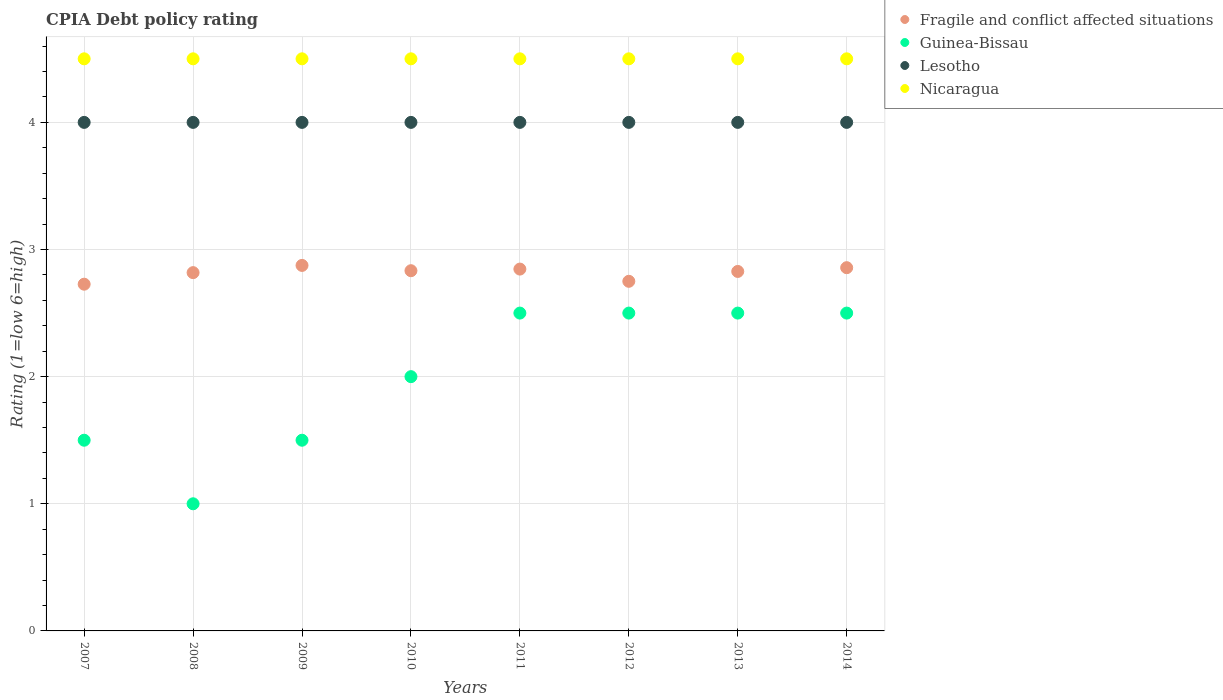Is the number of dotlines equal to the number of legend labels?
Provide a succinct answer. Yes. Across all years, what is the maximum CPIA rating in Lesotho?
Your response must be concise. 4. Across all years, what is the minimum CPIA rating in Lesotho?
Your answer should be very brief. 4. What is the total CPIA rating in Lesotho in the graph?
Keep it short and to the point. 32. In the year 2007, what is the difference between the CPIA rating in Fragile and conflict affected situations and CPIA rating in Guinea-Bissau?
Offer a very short reply. 1.23. In how many years, is the CPIA rating in Guinea-Bissau greater than 4.4?
Give a very brief answer. 0. Is the CPIA rating in Fragile and conflict affected situations in 2010 less than that in 2013?
Provide a succinct answer. No. Is the difference between the CPIA rating in Fragile and conflict affected situations in 2007 and 2009 greater than the difference between the CPIA rating in Guinea-Bissau in 2007 and 2009?
Keep it short and to the point. No. Is the sum of the CPIA rating in Nicaragua in 2008 and 2014 greater than the maximum CPIA rating in Guinea-Bissau across all years?
Provide a short and direct response. Yes. How many dotlines are there?
Ensure brevity in your answer.  4. Does the graph contain any zero values?
Provide a short and direct response. No. Where does the legend appear in the graph?
Give a very brief answer. Top right. How many legend labels are there?
Provide a short and direct response. 4. What is the title of the graph?
Offer a very short reply. CPIA Debt policy rating. Does "Luxembourg" appear as one of the legend labels in the graph?
Provide a succinct answer. No. What is the Rating (1=low 6=high) of Fragile and conflict affected situations in 2007?
Your answer should be very brief. 2.73. What is the Rating (1=low 6=high) in Nicaragua in 2007?
Provide a succinct answer. 4.5. What is the Rating (1=low 6=high) in Fragile and conflict affected situations in 2008?
Your response must be concise. 2.82. What is the Rating (1=low 6=high) of Lesotho in 2008?
Make the answer very short. 4. What is the Rating (1=low 6=high) of Fragile and conflict affected situations in 2009?
Provide a succinct answer. 2.88. What is the Rating (1=low 6=high) in Lesotho in 2009?
Provide a short and direct response. 4. What is the Rating (1=low 6=high) of Fragile and conflict affected situations in 2010?
Provide a short and direct response. 2.83. What is the Rating (1=low 6=high) in Guinea-Bissau in 2010?
Provide a short and direct response. 2. What is the Rating (1=low 6=high) in Nicaragua in 2010?
Give a very brief answer. 4.5. What is the Rating (1=low 6=high) in Fragile and conflict affected situations in 2011?
Your response must be concise. 2.85. What is the Rating (1=low 6=high) in Nicaragua in 2011?
Keep it short and to the point. 4.5. What is the Rating (1=low 6=high) of Fragile and conflict affected situations in 2012?
Provide a short and direct response. 2.75. What is the Rating (1=low 6=high) in Guinea-Bissau in 2012?
Provide a succinct answer. 2.5. What is the Rating (1=low 6=high) of Lesotho in 2012?
Your answer should be very brief. 4. What is the Rating (1=low 6=high) in Fragile and conflict affected situations in 2013?
Provide a short and direct response. 2.83. What is the Rating (1=low 6=high) in Guinea-Bissau in 2013?
Your answer should be compact. 2.5. What is the Rating (1=low 6=high) of Fragile and conflict affected situations in 2014?
Your answer should be very brief. 2.86. What is the Rating (1=low 6=high) in Guinea-Bissau in 2014?
Keep it short and to the point. 2.5. Across all years, what is the maximum Rating (1=low 6=high) of Fragile and conflict affected situations?
Offer a terse response. 2.88. Across all years, what is the maximum Rating (1=low 6=high) in Guinea-Bissau?
Give a very brief answer. 2.5. Across all years, what is the minimum Rating (1=low 6=high) of Fragile and conflict affected situations?
Provide a succinct answer. 2.73. Across all years, what is the minimum Rating (1=low 6=high) of Guinea-Bissau?
Give a very brief answer. 1. Across all years, what is the minimum Rating (1=low 6=high) in Nicaragua?
Provide a succinct answer. 4.5. What is the total Rating (1=low 6=high) in Fragile and conflict affected situations in the graph?
Give a very brief answer. 22.53. What is the total Rating (1=low 6=high) of Lesotho in the graph?
Provide a short and direct response. 32. What is the total Rating (1=low 6=high) of Nicaragua in the graph?
Keep it short and to the point. 36. What is the difference between the Rating (1=low 6=high) of Fragile and conflict affected situations in 2007 and that in 2008?
Offer a very short reply. -0.09. What is the difference between the Rating (1=low 6=high) in Lesotho in 2007 and that in 2008?
Provide a short and direct response. 0. What is the difference between the Rating (1=low 6=high) of Nicaragua in 2007 and that in 2008?
Offer a very short reply. 0. What is the difference between the Rating (1=low 6=high) in Fragile and conflict affected situations in 2007 and that in 2009?
Provide a succinct answer. -0.15. What is the difference between the Rating (1=low 6=high) of Lesotho in 2007 and that in 2009?
Ensure brevity in your answer.  0. What is the difference between the Rating (1=low 6=high) of Fragile and conflict affected situations in 2007 and that in 2010?
Offer a very short reply. -0.11. What is the difference between the Rating (1=low 6=high) in Fragile and conflict affected situations in 2007 and that in 2011?
Provide a succinct answer. -0.12. What is the difference between the Rating (1=low 6=high) in Guinea-Bissau in 2007 and that in 2011?
Keep it short and to the point. -1. What is the difference between the Rating (1=low 6=high) in Nicaragua in 2007 and that in 2011?
Make the answer very short. 0. What is the difference between the Rating (1=low 6=high) of Fragile and conflict affected situations in 2007 and that in 2012?
Offer a terse response. -0.02. What is the difference between the Rating (1=low 6=high) of Guinea-Bissau in 2007 and that in 2012?
Give a very brief answer. -1. What is the difference between the Rating (1=low 6=high) of Fragile and conflict affected situations in 2007 and that in 2013?
Ensure brevity in your answer.  -0.1. What is the difference between the Rating (1=low 6=high) of Lesotho in 2007 and that in 2013?
Give a very brief answer. 0. What is the difference between the Rating (1=low 6=high) of Nicaragua in 2007 and that in 2013?
Offer a very short reply. 0. What is the difference between the Rating (1=low 6=high) in Fragile and conflict affected situations in 2007 and that in 2014?
Ensure brevity in your answer.  -0.13. What is the difference between the Rating (1=low 6=high) in Guinea-Bissau in 2007 and that in 2014?
Your response must be concise. -1. What is the difference between the Rating (1=low 6=high) in Nicaragua in 2007 and that in 2014?
Your answer should be compact. 0. What is the difference between the Rating (1=low 6=high) of Fragile and conflict affected situations in 2008 and that in 2009?
Offer a very short reply. -0.06. What is the difference between the Rating (1=low 6=high) of Fragile and conflict affected situations in 2008 and that in 2010?
Offer a very short reply. -0.02. What is the difference between the Rating (1=low 6=high) of Nicaragua in 2008 and that in 2010?
Your answer should be compact. 0. What is the difference between the Rating (1=low 6=high) of Fragile and conflict affected situations in 2008 and that in 2011?
Your answer should be very brief. -0.03. What is the difference between the Rating (1=low 6=high) of Guinea-Bissau in 2008 and that in 2011?
Your answer should be very brief. -1.5. What is the difference between the Rating (1=low 6=high) in Nicaragua in 2008 and that in 2011?
Ensure brevity in your answer.  0. What is the difference between the Rating (1=low 6=high) of Fragile and conflict affected situations in 2008 and that in 2012?
Offer a very short reply. 0.07. What is the difference between the Rating (1=low 6=high) of Guinea-Bissau in 2008 and that in 2012?
Offer a terse response. -1.5. What is the difference between the Rating (1=low 6=high) of Nicaragua in 2008 and that in 2012?
Offer a terse response. 0. What is the difference between the Rating (1=low 6=high) in Fragile and conflict affected situations in 2008 and that in 2013?
Make the answer very short. -0.01. What is the difference between the Rating (1=low 6=high) of Lesotho in 2008 and that in 2013?
Give a very brief answer. 0. What is the difference between the Rating (1=low 6=high) in Nicaragua in 2008 and that in 2013?
Offer a very short reply. 0. What is the difference between the Rating (1=low 6=high) in Fragile and conflict affected situations in 2008 and that in 2014?
Offer a very short reply. -0.04. What is the difference between the Rating (1=low 6=high) in Guinea-Bissau in 2008 and that in 2014?
Offer a very short reply. -1.5. What is the difference between the Rating (1=low 6=high) in Nicaragua in 2008 and that in 2014?
Offer a very short reply. 0. What is the difference between the Rating (1=low 6=high) of Fragile and conflict affected situations in 2009 and that in 2010?
Your answer should be very brief. 0.04. What is the difference between the Rating (1=low 6=high) in Guinea-Bissau in 2009 and that in 2010?
Your answer should be compact. -0.5. What is the difference between the Rating (1=low 6=high) of Fragile and conflict affected situations in 2009 and that in 2011?
Your response must be concise. 0.03. What is the difference between the Rating (1=low 6=high) in Guinea-Bissau in 2009 and that in 2011?
Your answer should be compact. -1. What is the difference between the Rating (1=low 6=high) in Fragile and conflict affected situations in 2009 and that in 2012?
Your answer should be compact. 0.12. What is the difference between the Rating (1=low 6=high) of Guinea-Bissau in 2009 and that in 2012?
Your answer should be compact. -1. What is the difference between the Rating (1=low 6=high) of Lesotho in 2009 and that in 2012?
Your response must be concise. 0. What is the difference between the Rating (1=low 6=high) in Fragile and conflict affected situations in 2009 and that in 2013?
Offer a terse response. 0.05. What is the difference between the Rating (1=low 6=high) in Lesotho in 2009 and that in 2013?
Your response must be concise. 0. What is the difference between the Rating (1=low 6=high) of Fragile and conflict affected situations in 2009 and that in 2014?
Your answer should be very brief. 0.02. What is the difference between the Rating (1=low 6=high) in Guinea-Bissau in 2009 and that in 2014?
Your response must be concise. -1. What is the difference between the Rating (1=low 6=high) in Nicaragua in 2009 and that in 2014?
Your answer should be compact. 0. What is the difference between the Rating (1=low 6=high) in Fragile and conflict affected situations in 2010 and that in 2011?
Give a very brief answer. -0.01. What is the difference between the Rating (1=low 6=high) in Lesotho in 2010 and that in 2011?
Your response must be concise. 0. What is the difference between the Rating (1=low 6=high) in Nicaragua in 2010 and that in 2011?
Your response must be concise. 0. What is the difference between the Rating (1=low 6=high) in Fragile and conflict affected situations in 2010 and that in 2012?
Your response must be concise. 0.08. What is the difference between the Rating (1=low 6=high) in Lesotho in 2010 and that in 2012?
Provide a short and direct response. 0. What is the difference between the Rating (1=low 6=high) of Nicaragua in 2010 and that in 2012?
Provide a succinct answer. 0. What is the difference between the Rating (1=low 6=high) in Fragile and conflict affected situations in 2010 and that in 2013?
Give a very brief answer. 0.01. What is the difference between the Rating (1=low 6=high) of Lesotho in 2010 and that in 2013?
Provide a short and direct response. 0. What is the difference between the Rating (1=low 6=high) of Nicaragua in 2010 and that in 2013?
Offer a terse response. 0. What is the difference between the Rating (1=low 6=high) in Fragile and conflict affected situations in 2010 and that in 2014?
Keep it short and to the point. -0.02. What is the difference between the Rating (1=low 6=high) of Lesotho in 2010 and that in 2014?
Your answer should be very brief. 0. What is the difference between the Rating (1=low 6=high) in Fragile and conflict affected situations in 2011 and that in 2012?
Make the answer very short. 0.1. What is the difference between the Rating (1=low 6=high) in Fragile and conflict affected situations in 2011 and that in 2013?
Offer a terse response. 0.02. What is the difference between the Rating (1=low 6=high) in Fragile and conflict affected situations in 2011 and that in 2014?
Your answer should be very brief. -0.01. What is the difference between the Rating (1=low 6=high) in Guinea-Bissau in 2011 and that in 2014?
Provide a succinct answer. 0. What is the difference between the Rating (1=low 6=high) in Lesotho in 2011 and that in 2014?
Your answer should be compact. 0. What is the difference between the Rating (1=low 6=high) in Fragile and conflict affected situations in 2012 and that in 2013?
Give a very brief answer. -0.08. What is the difference between the Rating (1=low 6=high) in Guinea-Bissau in 2012 and that in 2013?
Your answer should be compact. 0. What is the difference between the Rating (1=low 6=high) in Lesotho in 2012 and that in 2013?
Provide a short and direct response. 0. What is the difference between the Rating (1=low 6=high) in Nicaragua in 2012 and that in 2013?
Offer a terse response. 0. What is the difference between the Rating (1=low 6=high) in Fragile and conflict affected situations in 2012 and that in 2014?
Your response must be concise. -0.11. What is the difference between the Rating (1=low 6=high) of Guinea-Bissau in 2012 and that in 2014?
Give a very brief answer. 0. What is the difference between the Rating (1=low 6=high) of Nicaragua in 2012 and that in 2014?
Make the answer very short. 0. What is the difference between the Rating (1=low 6=high) in Fragile and conflict affected situations in 2013 and that in 2014?
Provide a short and direct response. -0.03. What is the difference between the Rating (1=low 6=high) of Guinea-Bissau in 2013 and that in 2014?
Give a very brief answer. 0. What is the difference between the Rating (1=low 6=high) in Fragile and conflict affected situations in 2007 and the Rating (1=low 6=high) in Guinea-Bissau in 2008?
Your response must be concise. 1.73. What is the difference between the Rating (1=low 6=high) in Fragile and conflict affected situations in 2007 and the Rating (1=low 6=high) in Lesotho in 2008?
Your answer should be very brief. -1.27. What is the difference between the Rating (1=low 6=high) in Fragile and conflict affected situations in 2007 and the Rating (1=low 6=high) in Nicaragua in 2008?
Offer a terse response. -1.77. What is the difference between the Rating (1=low 6=high) in Guinea-Bissau in 2007 and the Rating (1=low 6=high) in Nicaragua in 2008?
Your answer should be very brief. -3. What is the difference between the Rating (1=low 6=high) in Lesotho in 2007 and the Rating (1=low 6=high) in Nicaragua in 2008?
Keep it short and to the point. -0.5. What is the difference between the Rating (1=low 6=high) in Fragile and conflict affected situations in 2007 and the Rating (1=low 6=high) in Guinea-Bissau in 2009?
Make the answer very short. 1.23. What is the difference between the Rating (1=low 6=high) of Fragile and conflict affected situations in 2007 and the Rating (1=low 6=high) of Lesotho in 2009?
Offer a terse response. -1.27. What is the difference between the Rating (1=low 6=high) of Fragile and conflict affected situations in 2007 and the Rating (1=low 6=high) of Nicaragua in 2009?
Your answer should be compact. -1.77. What is the difference between the Rating (1=low 6=high) in Guinea-Bissau in 2007 and the Rating (1=low 6=high) in Nicaragua in 2009?
Offer a very short reply. -3. What is the difference between the Rating (1=low 6=high) in Lesotho in 2007 and the Rating (1=low 6=high) in Nicaragua in 2009?
Offer a terse response. -0.5. What is the difference between the Rating (1=low 6=high) of Fragile and conflict affected situations in 2007 and the Rating (1=low 6=high) of Guinea-Bissau in 2010?
Your answer should be very brief. 0.73. What is the difference between the Rating (1=low 6=high) of Fragile and conflict affected situations in 2007 and the Rating (1=low 6=high) of Lesotho in 2010?
Provide a succinct answer. -1.27. What is the difference between the Rating (1=low 6=high) of Fragile and conflict affected situations in 2007 and the Rating (1=low 6=high) of Nicaragua in 2010?
Give a very brief answer. -1.77. What is the difference between the Rating (1=low 6=high) in Fragile and conflict affected situations in 2007 and the Rating (1=low 6=high) in Guinea-Bissau in 2011?
Your answer should be compact. 0.23. What is the difference between the Rating (1=low 6=high) of Fragile and conflict affected situations in 2007 and the Rating (1=low 6=high) of Lesotho in 2011?
Offer a very short reply. -1.27. What is the difference between the Rating (1=low 6=high) of Fragile and conflict affected situations in 2007 and the Rating (1=low 6=high) of Nicaragua in 2011?
Offer a terse response. -1.77. What is the difference between the Rating (1=low 6=high) of Guinea-Bissau in 2007 and the Rating (1=low 6=high) of Lesotho in 2011?
Your response must be concise. -2.5. What is the difference between the Rating (1=low 6=high) of Fragile and conflict affected situations in 2007 and the Rating (1=low 6=high) of Guinea-Bissau in 2012?
Ensure brevity in your answer.  0.23. What is the difference between the Rating (1=low 6=high) in Fragile and conflict affected situations in 2007 and the Rating (1=low 6=high) in Lesotho in 2012?
Ensure brevity in your answer.  -1.27. What is the difference between the Rating (1=low 6=high) of Fragile and conflict affected situations in 2007 and the Rating (1=low 6=high) of Nicaragua in 2012?
Offer a very short reply. -1.77. What is the difference between the Rating (1=low 6=high) in Guinea-Bissau in 2007 and the Rating (1=low 6=high) in Nicaragua in 2012?
Your answer should be very brief. -3. What is the difference between the Rating (1=low 6=high) in Lesotho in 2007 and the Rating (1=low 6=high) in Nicaragua in 2012?
Make the answer very short. -0.5. What is the difference between the Rating (1=low 6=high) of Fragile and conflict affected situations in 2007 and the Rating (1=low 6=high) of Guinea-Bissau in 2013?
Your response must be concise. 0.23. What is the difference between the Rating (1=low 6=high) of Fragile and conflict affected situations in 2007 and the Rating (1=low 6=high) of Lesotho in 2013?
Make the answer very short. -1.27. What is the difference between the Rating (1=low 6=high) of Fragile and conflict affected situations in 2007 and the Rating (1=low 6=high) of Nicaragua in 2013?
Make the answer very short. -1.77. What is the difference between the Rating (1=low 6=high) in Lesotho in 2007 and the Rating (1=low 6=high) in Nicaragua in 2013?
Ensure brevity in your answer.  -0.5. What is the difference between the Rating (1=low 6=high) of Fragile and conflict affected situations in 2007 and the Rating (1=low 6=high) of Guinea-Bissau in 2014?
Make the answer very short. 0.23. What is the difference between the Rating (1=low 6=high) of Fragile and conflict affected situations in 2007 and the Rating (1=low 6=high) of Lesotho in 2014?
Ensure brevity in your answer.  -1.27. What is the difference between the Rating (1=low 6=high) of Fragile and conflict affected situations in 2007 and the Rating (1=low 6=high) of Nicaragua in 2014?
Make the answer very short. -1.77. What is the difference between the Rating (1=low 6=high) of Guinea-Bissau in 2007 and the Rating (1=low 6=high) of Lesotho in 2014?
Your response must be concise. -2.5. What is the difference between the Rating (1=low 6=high) of Lesotho in 2007 and the Rating (1=low 6=high) of Nicaragua in 2014?
Ensure brevity in your answer.  -0.5. What is the difference between the Rating (1=low 6=high) in Fragile and conflict affected situations in 2008 and the Rating (1=low 6=high) in Guinea-Bissau in 2009?
Give a very brief answer. 1.32. What is the difference between the Rating (1=low 6=high) of Fragile and conflict affected situations in 2008 and the Rating (1=low 6=high) of Lesotho in 2009?
Ensure brevity in your answer.  -1.18. What is the difference between the Rating (1=low 6=high) of Fragile and conflict affected situations in 2008 and the Rating (1=low 6=high) of Nicaragua in 2009?
Provide a short and direct response. -1.68. What is the difference between the Rating (1=low 6=high) in Guinea-Bissau in 2008 and the Rating (1=low 6=high) in Lesotho in 2009?
Make the answer very short. -3. What is the difference between the Rating (1=low 6=high) of Lesotho in 2008 and the Rating (1=low 6=high) of Nicaragua in 2009?
Provide a succinct answer. -0.5. What is the difference between the Rating (1=low 6=high) in Fragile and conflict affected situations in 2008 and the Rating (1=low 6=high) in Guinea-Bissau in 2010?
Keep it short and to the point. 0.82. What is the difference between the Rating (1=low 6=high) in Fragile and conflict affected situations in 2008 and the Rating (1=low 6=high) in Lesotho in 2010?
Offer a terse response. -1.18. What is the difference between the Rating (1=low 6=high) of Fragile and conflict affected situations in 2008 and the Rating (1=low 6=high) of Nicaragua in 2010?
Your answer should be very brief. -1.68. What is the difference between the Rating (1=low 6=high) in Guinea-Bissau in 2008 and the Rating (1=low 6=high) in Lesotho in 2010?
Provide a succinct answer. -3. What is the difference between the Rating (1=low 6=high) in Guinea-Bissau in 2008 and the Rating (1=low 6=high) in Nicaragua in 2010?
Make the answer very short. -3.5. What is the difference between the Rating (1=low 6=high) of Lesotho in 2008 and the Rating (1=low 6=high) of Nicaragua in 2010?
Ensure brevity in your answer.  -0.5. What is the difference between the Rating (1=low 6=high) in Fragile and conflict affected situations in 2008 and the Rating (1=low 6=high) in Guinea-Bissau in 2011?
Ensure brevity in your answer.  0.32. What is the difference between the Rating (1=low 6=high) of Fragile and conflict affected situations in 2008 and the Rating (1=low 6=high) of Lesotho in 2011?
Your answer should be compact. -1.18. What is the difference between the Rating (1=low 6=high) of Fragile and conflict affected situations in 2008 and the Rating (1=low 6=high) of Nicaragua in 2011?
Offer a very short reply. -1.68. What is the difference between the Rating (1=low 6=high) of Guinea-Bissau in 2008 and the Rating (1=low 6=high) of Lesotho in 2011?
Your answer should be very brief. -3. What is the difference between the Rating (1=low 6=high) of Fragile and conflict affected situations in 2008 and the Rating (1=low 6=high) of Guinea-Bissau in 2012?
Ensure brevity in your answer.  0.32. What is the difference between the Rating (1=low 6=high) of Fragile and conflict affected situations in 2008 and the Rating (1=low 6=high) of Lesotho in 2012?
Give a very brief answer. -1.18. What is the difference between the Rating (1=low 6=high) in Fragile and conflict affected situations in 2008 and the Rating (1=low 6=high) in Nicaragua in 2012?
Ensure brevity in your answer.  -1.68. What is the difference between the Rating (1=low 6=high) in Guinea-Bissau in 2008 and the Rating (1=low 6=high) in Nicaragua in 2012?
Your response must be concise. -3.5. What is the difference between the Rating (1=low 6=high) of Lesotho in 2008 and the Rating (1=low 6=high) of Nicaragua in 2012?
Offer a terse response. -0.5. What is the difference between the Rating (1=low 6=high) in Fragile and conflict affected situations in 2008 and the Rating (1=low 6=high) in Guinea-Bissau in 2013?
Offer a terse response. 0.32. What is the difference between the Rating (1=low 6=high) of Fragile and conflict affected situations in 2008 and the Rating (1=low 6=high) of Lesotho in 2013?
Give a very brief answer. -1.18. What is the difference between the Rating (1=low 6=high) in Fragile and conflict affected situations in 2008 and the Rating (1=low 6=high) in Nicaragua in 2013?
Offer a terse response. -1.68. What is the difference between the Rating (1=low 6=high) in Guinea-Bissau in 2008 and the Rating (1=low 6=high) in Nicaragua in 2013?
Ensure brevity in your answer.  -3.5. What is the difference between the Rating (1=low 6=high) in Lesotho in 2008 and the Rating (1=low 6=high) in Nicaragua in 2013?
Your answer should be very brief. -0.5. What is the difference between the Rating (1=low 6=high) in Fragile and conflict affected situations in 2008 and the Rating (1=low 6=high) in Guinea-Bissau in 2014?
Your response must be concise. 0.32. What is the difference between the Rating (1=low 6=high) in Fragile and conflict affected situations in 2008 and the Rating (1=low 6=high) in Lesotho in 2014?
Your answer should be compact. -1.18. What is the difference between the Rating (1=low 6=high) in Fragile and conflict affected situations in 2008 and the Rating (1=low 6=high) in Nicaragua in 2014?
Your answer should be very brief. -1.68. What is the difference between the Rating (1=low 6=high) in Guinea-Bissau in 2008 and the Rating (1=low 6=high) in Lesotho in 2014?
Make the answer very short. -3. What is the difference between the Rating (1=low 6=high) in Guinea-Bissau in 2008 and the Rating (1=low 6=high) in Nicaragua in 2014?
Your answer should be very brief. -3.5. What is the difference between the Rating (1=low 6=high) of Fragile and conflict affected situations in 2009 and the Rating (1=low 6=high) of Guinea-Bissau in 2010?
Your answer should be very brief. 0.88. What is the difference between the Rating (1=low 6=high) of Fragile and conflict affected situations in 2009 and the Rating (1=low 6=high) of Lesotho in 2010?
Provide a short and direct response. -1.12. What is the difference between the Rating (1=low 6=high) of Fragile and conflict affected situations in 2009 and the Rating (1=low 6=high) of Nicaragua in 2010?
Your response must be concise. -1.62. What is the difference between the Rating (1=low 6=high) in Guinea-Bissau in 2009 and the Rating (1=low 6=high) in Lesotho in 2010?
Your answer should be compact. -2.5. What is the difference between the Rating (1=low 6=high) of Guinea-Bissau in 2009 and the Rating (1=low 6=high) of Nicaragua in 2010?
Your answer should be compact. -3. What is the difference between the Rating (1=low 6=high) in Fragile and conflict affected situations in 2009 and the Rating (1=low 6=high) in Guinea-Bissau in 2011?
Your answer should be very brief. 0.38. What is the difference between the Rating (1=low 6=high) of Fragile and conflict affected situations in 2009 and the Rating (1=low 6=high) of Lesotho in 2011?
Offer a very short reply. -1.12. What is the difference between the Rating (1=low 6=high) of Fragile and conflict affected situations in 2009 and the Rating (1=low 6=high) of Nicaragua in 2011?
Your response must be concise. -1.62. What is the difference between the Rating (1=low 6=high) in Guinea-Bissau in 2009 and the Rating (1=low 6=high) in Lesotho in 2011?
Your answer should be very brief. -2.5. What is the difference between the Rating (1=low 6=high) of Guinea-Bissau in 2009 and the Rating (1=low 6=high) of Nicaragua in 2011?
Provide a succinct answer. -3. What is the difference between the Rating (1=low 6=high) of Lesotho in 2009 and the Rating (1=low 6=high) of Nicaragua in 2011?
Give a very brief answer. -0.5. What is the difference between the Rating (1=low 6=high) in Fragile and conflict affected situations in 2009 and the Rating (1=low 6=high) in Guinea-Bissau in 2012?
Your answer should be very brief. 0.38. What is the difference between the Rating (1=low 6=high) of Fragile and conflict affected situations in 2009 and the Rating (1=low 6=high) of Lesotho in 2012?
Keep it short and to the point. -1.12. What is the difference between the Rating (1=low 6=high) in Fragile and conflict affected situations in 2009 and the Rating (1=low 6=high) in Nicaragua in 2012?
Your answer should be compact. -1.62. What is the difference between the Rating (1=low 6=high) in Guinea-Bissau in 2009 and the Rating (1=low 6=high) in Nicaragua in 2012?
Make the answer very short. -3. What is the difference between the Rating (1=low 6=high) in Fragile and conflict affected situations in 2009 and the Rating (1=low 6=high) in Lesotho in 2013?
Give a very brief answer. -1.12. What is the difference between the Rating (1=low 6=high) of Fragile and conflict affected situations in 2009 and the Rating (1=low 6=high) of Nicaragua in 2013?
Provide a short and direct response. -1.62. What is the difference between the Rating (1=low 6=high) in Guinea-Bissau in 2009 and the Rating (1=low 6=high) in Lesotho in 2013?
Ensure brevity in your answer.  -2.5. What is the difference between the Rating (1=low 6=high) of Guinea-Bissau in 2009 and the Rating (1=low 6=high) of Nicaragua in 2013?
Give a very brief answer. -3. What is the difference between the Rating (1=low 6=high) in Fragile and conflict affected situations in 2009 and the Rating (1=low 6=high) in Guinea-Bissau in 2014?
Provide a succinct answer. 0.38. What is the difference between the Rating (1=low 6=high) of Fragile and conflict affected situations in 2009 and the Rating (1=low 6=high) of Lesotho in 2014?
Provide a succinct answer. -1.12. What is the difference between the Rating (1=low 6=high) in Fragile and conflict affected situations in 2009 and the Rating (1=low 6=high) in Nicaragua in 2014?
Your answer should be compact. -1.62. What is the difference between the Rating (1=low 6=high) in Lesotho in 2009 and the Rating (1=low 6=high) in Nicaragua in 2014?
Offer a terse response. -0.5. What is the difference between the Rating (1=low 6=high) of Fragile and conflict affected situations in 2010 and the Rating (1=low 6=high) of Guinea-Bissau in 2011?
Ensure brevity in your answer.  0.33. What is the difference between the Rating (1=low 6=high) of Fragile and conflict affected situations in 2010 and the Rating (1=low 6=high) of Lesotho in 2011?
Your response must be concise. -1.17. What is the difference between the Rating (1=low 6=high) of Fragile and conflict affected situations in 2010 and the Rating (1=low 6=high) of Nicaragua in 2011?
Give a very brief answer. -1.67. What is the difference between the Rating (1=low 6=high) of Guinea-Bissau in 2010 and the Rating (1=low 6=high) of Lesotho in 2011?
Provide a succinct answer. -2. What is the difference between the Rating (1=low 6=high) of Guinea-Bissau in 2010 and the Rating (1=low 6=high) of Nicaragua in 2011?
Your answer should be very brief. -2.5. What is the difference between the Rating (1=low 6=high) in Fragile and conflict affected situations in 2010 and the Rating (1=low 6=high) in Lesotho in 2012?
Keep it short and to the point. -1.17. What is the difference between the Rating (1=low 6=high) of Fragile and conflict affected situations in 2010 and the Rating (1=low 6=high) of Nicaragua in 2012?
Offer a terse response. -1.67. What is the difference between the Rating (1=low 6=high) in Guinea-Bissau in 2010 and the Rating (1=low 6=high) in Nicaragua in 2012?
Provide a short and direct response. -2.5. What is the difference between the Rating (1=low 6=high) in Lesotho in 2010 and the Rating (1=low 6=high) in Nicaragua in 2012?
Make the answer very short. -0.5. What is the difference between the Rating (1=low 6=high) of Fragile and conflict affected situations in 2010 and the Rating (1=low 6=high) of Lesotho in 2013?
Keep it short and to the point. -1.17. What is the difference between the Rating (1=low 6=high) in Fragile and conflict affected situations in 2010 and the Rating (1=low 6=high) in Nicaragua in 2013?
Provide a short and direct response. -1.67. What is the difference between the Rating (1=low 6=high) of Lesotho in 2010 and the Rating (1=low 6=high) of Nicaragua in 2013?
Ensure brevity in your answer.  -0.5. What is the difference between the Rating (1=low 6=high) in Fragile and conflict affected situations in 2010 and the Rating (1=low 6=high) in Lesotho in 2014?
Your answer should be very brief. -1.17. What is the difference between the Rating (1=low 6=high) of Fragile and conflict affected situations in 2010 and the Rating (1=low 6=high) of Nicaragua in 2014?
Provide a short and direct response. -1.67. What is the difference between the Rating (1=low 6=high) in Guinea-Bissau in 2010 and the Rating (1=low 6=high) in Lesotho in 2014?
Your answer should be very brief. -2. What is the difference between the Rating (1=low 6=high) in Lesotho in 2010 and the Rating (1=low 6=high) in Nicaragua in 2014?
Provide a short and direct response. -0.5. What is the difference between the Rating (1=low 6=high) of Fragile and conflict affected situations in 2011 and the Rating (1=low 6=high) of Guinea-Bissau in 2012?
Provide a short and direct response. 0.35. What is the difference between the Rating (1=low 6=high) in Fragile and conflict affected situations in 2011 and the Rating (1=low 6=high) in Lesotho in 2012?
Provide a short and direct response. -1.15. What is the difference between the Rating (1=low 6=high) of Fragile and conflict affected situations in 2011 and the Rating (1=low 6=high) of Nicaragua in 2012?
Your answer should be compact. -1.65. What is the difference between the Rating (1=low 6=high) of Guinea-Bissau in 2011 and the Rating (1=low 6=high) of Nicaragua in 2012?
Make the answer very short. -2. What is the difference between the Rating (1=low 6=high) of Fragile and conflict affected situations in 2011 and the Rating (1=low 6=high) of Guinea-Bissau in 2013?
Your response must be concise. 0.35. What is the difference between the Rating (1=low 6=high) in Fragile and conflict affected situations in 2011 and the Rating (1=low 6=high) in Lesotho in 2013?
Offer a terse response. -1.15. What is the difference between the Rating (1=low 6=high) in Fragile and conflict affected situations in 2011 and the Rating (1=low 6=high) in Nicaragua in 2013?
Your answer should be very brief. -1.65. What is the difference between the Rating (1=low 6=high) of Guinea-Bissau in 2011 and the Rating (1=low 6=high) of Nicaragua in 2013?
Offer a terse response. -2. What is the difference between the Rating (1=low 6=high) of Lesotho in 2011 and the Rating (1=low 6=high) of Nicaragua in 2013?
Your answer should be compact. -0.5. What is the difference between the Rating (1=low 6=high) of Fragile and conflict affected situations in 2011 and the Rating (1=low 6=high) of Guinea-Bissau in 2014?
Give a very brief answer. 0.35. What is the difference between the Rating (1=low 6=high) of Fragile and conflict affected situations in 2011 and the Rating (1=low 6=high) of Lesotho in 2014?
Provide a short and direct response. -1.15. What is the difference between the Rating (1=low 6=high) of Fragile and conflict affected situations in 2011 and the Rating (1=low 6=high) of Nicaragua in 2014?
Offer a very short reply. -1.65. What is the difference between the Rating (1=low 6=high) in Lesotho in 2011 and the Rating (1=low 6=high) in Nicaragua in 2014?
Give a very brief answer. -0.5. What is the difference between the Rating (1=low 6=high) of Fragile and conflict affected situations in 2012 and the Rating (1=low 6=high) of Lesotho in 2013?
Make the answer very short. -1.25. What is the difference between the Rating (1=low 6=high) in Fragile and conflict affected situations in 2012 and the Rating (1=low 6=high) in Nicaragua in 2013?
Your answer should be compact. -1.75. What is the difference between the Rating (1=low 6=high) of Guinea-Bissau in 2012 and the Rating (1=low 6=high) of Lesotho in 2013?
Your answer should be compact. -1.5. What is the difference between the Rating (1=low 6=high) of Fragile and conflict affected situations in 2012 and the Rating (1=low 6=high) of Lesotho in 2014?
Keep it short and to the point. -1.25. What is the difference between the Rating (1=low 6=high) of Fragile and conflict affected situations in 2012 and the Rating (1=low 6=high) of Nicaragua in 2014?
Make the answer very short. -1.75. What is the difference between the Rating (1=low 6=high) in Guinea-Bissau in 2012 and the Rating (1=low 6=high) in Lesotho in 2014?
Your answer should be very brief. -1.5. What is the difference between the Rating (1=low 6=high) of Lesotho in 2012 and the Rating (1=low 6=high) of Nicaragua in 2014?
Provide a succinct answer. -0.5. What is the difference between the Rating (1=low 6=high) of Fragile and conflict affected situations in 2013 and the Rating (1=low 6=high) of Guinea-Bissau in 2014?
Offer a terse response. 0.33. What is the difference between the Rating (1=low 6=high) of Fragile and conflict affected situations in 2013 and the Rating (1=low 6=high) of Lesotho in 2014?
Offer a very short reply. -1.17. What is the difference between the Rating (1=low 6=high) in Fragile and conflict affected situations in 2013 and the Rating (1=low 6=high) in Nicaragua in 2014?
Your answer should be compact. -1.67. What is the difference between the Rating (1=low 6=high) of Guinea-Bissau in 2013 and the Rating (1=low 6=high) of Lesotho in 2014?
Make the answer very short. -1.5. What is the difference between the Rating (1=low 6=high) in Lesotho in 2013 and the Rating (1=low 6=high) in Nicaragua in 2014?
Give a very brief answer. -0.5. What is the average Rating (1=low 6=high) of Fragile and conflict affected situations per year?
Offer a terse response. 2.82. What is the average Rating (1=low 6=high) of Guinea-Bissau per year?
Provide a short and direct response. 2. In the year 2007, what is the difference between the Rating (1=low 6=high) of Fragile and conflict affected situations and Rating (1=low 6=high) of Guinea-Bissau?
Provide a succinct answer. 1.23. In the year 2007, what is the difference between the Rating (1=low 6=high) in Fragile and conflict affected situations and Rating (1=low 6=high) in Lesotho?
Your answer should be compact. -1.27. In the year 2007, what is the difference between the Rating (1=low 6=high) in Fragile and conflict affected situations and Rating (1=low 6=high) in Nicaragua?
Provide a succinct answer. -1.77. In the year 2007, what is the difference between the Rating (1=low 6=high) in Guinea-Bissau and Rating (1=low 6=high) in Nicaragua?
Make the answer very short. -3. In the year 2008, what is the difference between the Rating (1=low 6=high) of Fragile and conflict affected situations and Rating (1=low 6=high) of Guinea-Bissau?
Offer a terse response. 1.82. In the year 2008, what is the difference between the Rating (1=low 6=high) in Fragile and conflict affected situations and Rating (1=low 6=high) in Lesotho?
Your response must be concise. -1.18. In the year 2008, what is the difference between the Rating (1=low 6=high) in Fragile and conflict affected situations and Rating (1=low 6=high) in Nicaragua?
Your answer should be compact. -1.68. In the year 2008, what is the difference between the Rating (1=low 6=high) of Guinea-Bissau and Rating (1=low 6=high) of Nicaragua?
Offer a very short reply. -3.5. In the year 2008, what is the difference between the Rating (1=low 6=high) of Lesotho and Rating (1=low 6=high) of Nicaragua?
Offer a terse response. -0.5. In the year 2009, what is the difference between the Rating (1=low 6=high) of Fragile and conflict affected situations and Rating (1=low 6=high) of Guinea-Bissau?
Give a very brief answer. 1.38. In the year 2009, what is the difference between the Rating (1=low 6=high) of Fragile and conflict affected situations and Rating (1=low 6=high) of Lesotho?
Provide a succinct answer. -1.12. In the year 2009, what is the difference between the Rating (1=low 6=high) of Fragile and conflict affected situations and Rating (1=low 6=high) of Nicaragua?
Keep it short and to the point. -1.62. In the year 2009, what is the difference between the Rating (1=low 6=high) of Guinea-Bissau and Rating (1=low 6=high) of Lesotho?
Provide a succinct answer. -2.5. In the year 2009, what is the difference between the Rating (1=low 6=high) in Guinea-Bissau and Rating (1=low 6=high) in Nicaragua?
Provide a short and direct response. -3. In the year 2010, what is the difference between the Rating (1=low 6=high) in Fragile and conflict affected situations and Rating (1=low 6=high) in Lesotho?
Your response must be concise. -1.17. In the year 2010, what is the difference between the Rating (1=low 6=high) of Fragile and conflict affected situations and Rating (1=low 6=high) of Nicaragua?
Your answer should be compact. -1.67. In the year 2010, what is the difference between the Rating (1=low 6=high) of Guinea-Bissau and Rating (1=low 6=high) of Lesotho?
Provide a short and direct response. -2. In the year 2011, what is the difference between the Rating (1=low 6=high) of Fragile and conflict affected situations and Rating (1=low 6=high) of Guinea-Bissau?
Keep it short and to the point. 0.35. In the year 2011, what is the difference between the Rating (1=low 6=high) of Fragile and conflict affected situations and Rating (1=low 6=high) of Lesotho?
Keep it short and to the point. -1.15. In the year 2011, what is the difference between the Rating (1=low 6=high) in Fragile and conflict affected situations and Rating (1=low 6=high) in Nicaragua?
Your answer should be compact. -1.65. In the year 2011, what is the difference between the Rating (1=low 6=high) of Guinea-Bissau and Rating (1=low 6=high) of Lesotho?
Your answer should be compact. -1.5. In the year 2012, what is the difference between the Rating (1=low 6=high) of Fragile and conflict affected situations and Rating (1=low 6=high) of Lesotho?
Make the answer very short. -1.25. In the year 2012, what is the difference between the Rating (1=low 6=high) in Fragile and conflict affected situations and Rating (1=low 6=high) in Nicaragua?
Offer a very short reply. -1.75. In the year 2012, what is the difference between the Rating (1=low 6=high) of Guinea-Bissau and Rating (1=low 6=high) of Nicaragua?
Provide a succinct answer. -2. In the year 2012, what is the difference between the Rating (1=low 6=high) of Lesotho and Rating (1=low 6=high) of Nicaragua?
Provide a short and direct response. -0.5. In the year 2013, what is the difference between the Rating (1=low 6=high) in Fragile and conflict affected situations and Rating (1=low 6=high) in Guinea-Bissau?
Your answer should be very brief. 0.33. In the year 2013, what is the difference between the Rating (1=low 6=high) of Fragile and conflict affected situations and Rating (1=low 6=high) of Lesotho?
Give a very brief answer. -1.17. In the year 2013, what is the difference between the Rating (1=low 6=high) in Fragile and conflict affected situations and Rating (1=low 6=high) in Nicaragua?
Provide a short and direct response. -1.67. In the year 2013, what is the difference between the Rating (1=low 6=high) in Guinea-Bissau and Rating (1=low 6=high) in Lesotho?
Offer a terse response. -1.5. In the year 2013, what is the difference between the Rating (1=low 6=high) of Guinea-Bissau and Rating (1=low 6=high) of Nicaragua?
Your answer should be very brief. -2. In the year 2013, what is the difference between the Rating (1=low 6=high) in Lesotho and Rating (1=low 6=high) in Nicaragua?
Your response must be concise. -0.5. In the year 2014, what is the difference between the Rating (1=low 6=high) of Fragile and conflict affected situations and Rating (1=low 6=high) of Guinea-Bissau?
Offer a terse response. 0.36. In the year 2014, what is the difference between the Rating (1=low 6=high) of Fragile and conflict affected situations and Rating (1=low 6=high) of Lesotho?
Offer a terse response. -1.14. In the year 2014, what is the difference between the Rating (1=low 6=high) in Fragile and conflict affected situations and Rating (1=low 6=high) in Nicaragua?
Offer a very short reply. -1.64. In the year 2014, what is the difference between the Rating (1=low 6=high) of Guinea-Bissau and Rating (1=low 6=high) of Lesotho?
Offer a terse response. -1.5. In the year 2014, what is the difference between the Rating (1=low 6=high) of Guinea-Bissau and Rating (1=low 6=high) of Nicaragua?
Ensure brevity in your answer.  -2. What is the ratio of the Rating (1=low 6=high) of Fragile and conflict affected situations in 2007 to that in 2009?
Offer a terse response. 0.95. What is the ratio of the Rating (1=low 6=high) in Guinea-Bissau in 2007 to that in 2009?
Provide a short and direct response. 1. What is the ratio of the Rating (1=low 6=high) of Fragile and conflict affected situations in 2007 to that in 2010?
Ensure brevity in your answer.  0.96. What is the ratio of the Rating (1=low 6=high) in Guinea-Bissau in 2007 to that in 2010?
Provide a succinct answer. 0.75. What is the ratio of the Rating (1=low 6=high) of Nicaragua in 2007 to that in 2010?
Keep it short and to the point. 1. What is the ratio of the Rating (1=low 6=high) of Fragile and conflict affected situations in 2007 to that in 2011?
Your response must be concise. 0.96. What is the ratio of the Rating (1=low 6=high) of Lesotho in 2007 to that in 2011?
Your response must be concise. 1. What is the ratio of the Rating (1=low 6=high) of Nicaragua in 2007 to that in 2012?
Keep it short and to the point. 1. What is the ratio of the Rating (1=low 6=high) in Fragile and conflict affected situations in 2007 to that in 2013?
Keep it short and to the point. 0.96. What is the ratio of the Rating (1=low 6=high) of Guinea-Bissau in 2007 to that in 2013?
Keep it short and to the point. 0.6. What is the ratio of the Rating (1=low 6=high) in Lesotho in 2007 to that in 2013?
Provide a short and direct response. 1. What is the ratio of the Rating (1=low 6=high) of Fragile and conflict affected situations in 2007 to that in 2014?
Your answer should be compact. 0.95. What is the ratio of the Rating (1=low 6=high) in Fragile and conflict affected situations in 2008 to that in 2009?
Offer a very short reply. 0.98. What is the ratio of the Rating (1=low 6=high) in Guinea-Bissau in 2008 to that in 2009?
Give a very brief answer. 0.67. What is the ratio of the Rating (1=low 6=high) of Lesotho in 2008 to that in 2009?
Provide a short and direct response. 1. What is the ratio of the Rating (1=low 6=high) in Nicaragua in 2008 to that in 2009?
Keep it short and to the point. 1. What is the ratio of the Rating (1=low 6=high) of Fragile and conflict affected situations in 2008 to that in 2011?
Keep it short and to the point. 0.99. What is the ratio of the Rating (1=low 6=high) of Fragile and conflict affected situations in 2008 to that in 2012?
Provide a short and direct response. 1.02. What is the ratio of the Rating (1=low 6=high) of Nicaragua in 2008 to that in 2012?
Your response must be concise. 1. What is the ratio of the Rating (1=low 6=high) in Guinea-Bissau in 2008 to that in 2013?
Give a very brief answer. 0.4. What is the ratio of the Rating (1=low 6=high) in Nicaragua in 2008 to that in 2013?
Provide a succinct answer. 1. What is the ratio of the Rating (1=low 6=high) of Fragile and conflict affected situations in 2008 to that in 2014?
Make the answer very short. 0.99. What is the ratio of the Rating (1=low 6=high) in Guinea-Bissau in 2008 to that in 2014?
Provide a succinct answer. 0.4. What is the ratio of the Rating (1=low 6=high) of Nicaragua in 2008 to that in 2014?
Offer a terse response. 1. What is the ratio of the Rating (1=low 6=high) of Fragile and conflict affected situations in 2009 to that in 2010?
Offer a very short reply. 1.01. What is the ratio of the Rating (1=low 6=high) in Guinea-Bissau in 2009 to that in 2010?
Give a very brief answer. 0.75. What is the ratio of the Rating (1=low 6=high) of Lesotho in 2009 to that in 2010?
Your response must be concise. 1. What is the ratio of the Rating (1=low 6=high) of Nicaragua in 2009 to that in 2010?
Provide a succinct answer. 1. What is the ratio of the Rating (1=low 6=high) in Fragile and conflict affected situations in 2009 to that in 2011?
Offer a very short reply. 1.01. What is the ratio of the Rating (1=low 6=high) of Guinea-Bissau in 2009 to that in 2011?
Offer a terse response. 0.6. What is the ratio of the Rating (1=low 6=high) in Lesotho in 2009 to that in 2011?
Offer a very short reply. 1. What is the ratio of the Rating (1=low 6=high) in Nicaragua in 2009 to that in 2011?
Your response must be concise. 1. What is the ratio of the Rating (1=low 6=high) in Fragile and conflict affected situations in 2009 to that in 2012?
Provide a short and direct response. 1.05. What is the ratio of the Rating (1=low 6=high) of Nicaragua in 2009 to that in 2012?
Ensure brevity in your answer.  1. What is the ratio of the Rating (1=low 6=high) in Fragile and conflict affected situations in 2009 to that in 2013?
Make the answer very short. 1.02. What is the ratio of the Rating (1=low 6=high) of Guinea-Bissau in 2009 to that in 2013?
Offer a very short reply. 0.6. What is the ratio of the Rating (1=low 6=high) of Lesotho in 2009 to that in 2013?
Provide a succinct answer. 1. What is the ratio of the Rating (1=low 6=high) in Lesotho in 2010 to that in 2011?
Provide a short and direct response. 1. What is the ratio of the Rating (1=low 6=high) in Nicaragua in 2010 to that in 2011?
Provide a short and direct response. 1. What is the ratio of the Rating (1=low 6=high) of Fragile and conflict affected situations in 2010 to that in 2012?
Provide a succinct answer. 1.03. What is the ratio of the Rating (1=low 6=high) of Lesotho in 2010 to that in 2012?
Ensure brevity in your answer.  1. What is the ratio of the Rating (1=low 6=high) in Nicaragua in 2010 to that in 2012?
Keep it short and to the point. 1. What is the ratio of the Rating (1=low 6=high) in Fragile and conflict affected situations in 2010 to that in 2013?
Ensure brevity in your answer.  1. What is the ratio of the Rating (1=low 6=high) of Guinea-Bissau in 2010 to that in 2013?
Ensure brevity in your answer.  0.8. What is the ratio of the Rating (1=low 6=high) of Lesotho in 2010 to that in 2014?
Give a very brief answer. 1. What is the ratio of the Rating (1=low 6=high) in Fragile and conflict affected situations in 2011 to that in 2012?
Give a very brief answer. 1.03. What is the ratio of the Rating (1=low 6=high) of Lesotho in 2011 to that in 2012?
Your answer should be compact. 1. What is the ratio of the Rating (1=low 6=high) in Fragile and conflict affected situations in 2011 to that in 2013?
Give a very brief answer. 1.01. What is the ratio of the Rating (1=low 6=high) in Nicaragua in 2011 to that in 2013?
Your answer should be very brief. 1. What is the ratio of the Rating (1=low 6=high) of Fragile and conflict affected situations in 2011 to that in 2014?
Offer a terse response. 1. What is the ratio of the Rating (1=low 6=high) of Guinea-Bissau in 2011 to that in 2014?
Your response must be concise. 1. What is the ratio of the Rating (1=low 6=high) in Fragile and conflict affected situations in 2012 to that in 2013?
Offer a very short reply. 0.97. What is the ratio of the Rating (1=low 6=high) in Guinea-Bissau in 2012 to that in 2013?
Provide a short and direct response. 1. What is the ratio of the Rating (1=low 6=high) in Fragile and conflict affected situations in 2012 to that in 2014?
Give a very brief answer. 0.96. What is the ratio of the Rating (1=low 6=high) in Guinea-Bissau in 2012 to that in 2014?
Offer a terse response. 1. What is the ratio of the Rating (1=low 6=high) of Nicaragua in 2012 to that in 2014?
Your response must be concise. 1. What is the ratio of the Rating (1=low 6=high) of Nicaragua in 2013 to that in 2014?
Give a very brief answer. 1. What is the difference between the highest and the second highest Rating (1=low 6=high) in Fragile and conflict affected situations?
Ensure brevity in your answer.  0.02. What is the difference between the highest and the lowest Rating (1=low 6=high) of Fragile and conflict affected situations?
Make the answer very short. 0.15. What is the difference between the highest and the lowest Rating (1=low 6=high) in Guinea-Bissau?
Ensure brevity in your answer.  1.5. 